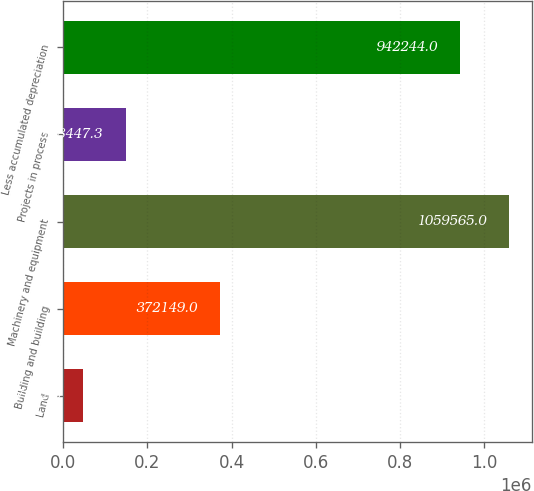<chart> <loc_0><loc_0><loc_500><loc_500><bar_chart><fcel>Land<fcel>Building and building<fcel>Machinery and equipment<fcel>Projects in process<fcel>Less accumulated depreciation<nl><fcel>47212<fcel>372149<fcel>1.05956e+06<fcel>148447<fcel>942244<nl></chart> 